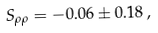Convert formula to latex. <formula><loc_0><loc_0><loc_500><loc_500>S _ { \rho \rho } = - 0 . 0 6 \pm 0 . 1 8 \, ,</formula> 